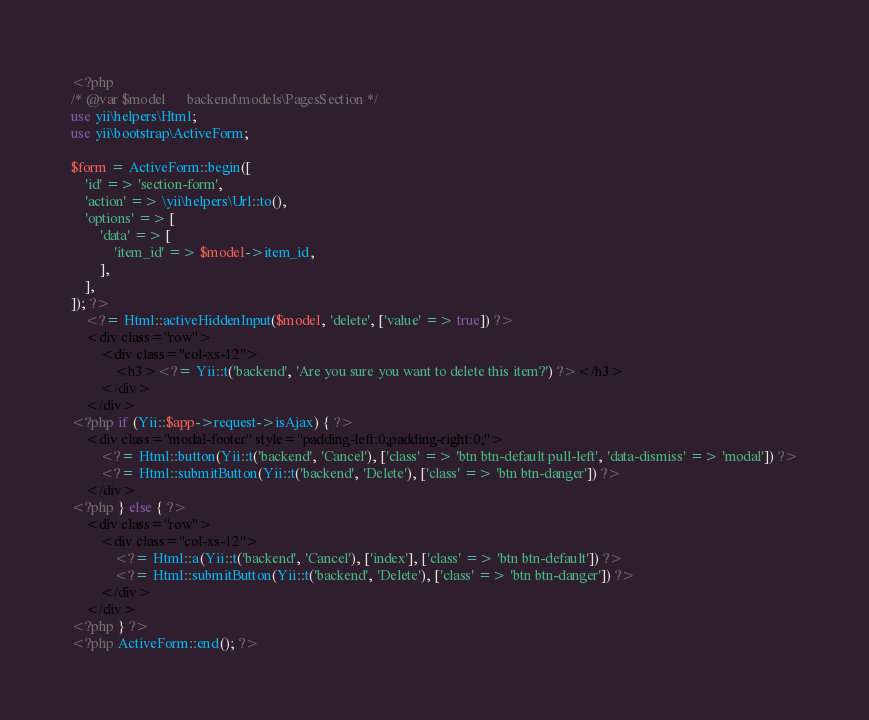<code> <loc_0><loc_0><loc_500><loc_500><_PHP_><?php
/* @var $model      backend\models\PagesSection */
use yii\helpers\Html;
use yii\bootstrap\ActiveForm;

$form = ActiveForm::begin([
    'id' => 'section-form',
    'action' => \yii\helpers\Url::to(),
    'options' => [
        'data' => [
            'item_id' => $model->item_id,
        ],
    ],
]); ?>
    <?= Html::activeHiddenInput($model, 'delete', ['value' => true]) ?>
    <div class="row">
        <div class="col-xs-12">
            <h3><?= Yii::t('backend', 'Are you sure you want to delete this item?') ?></h3>
        </div>
    </div>
<?php if (Yii::$app->request->isAjax) { ?>
    <div class="modal-footer" style="padding-left:0;padding-right:0;">
        <?= Html::button(Yii::t('backend', 'Cancel'), ['class' => 'btn btn-default pull-left', 'data-dismiss' => 'modal']) ?>
        <?= Html::submitButton(Yii::t('backend', 'Delete'), ['class' => 'btn btn-danger']) ?>
    </div>
<?php } else { ?>
    <div class="row">
        <div class="col-xs-12">
            <?= Html::a(Yii::t('backend', 'Cancel'), ['index'], ['class' => 'btn btn-default']) ?>
            <?= Html::submitButton(Yii::t('backend', 'Delete'), ['class' => 'btn btn-danger']) ?>
        </div>
    </div>
<?php } ?>
<?php ActiveForm::end(); ?></code> 